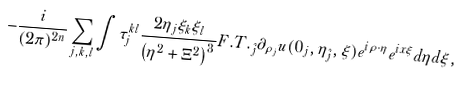<formula> <loc_0><loc_0><loc_500><loc_500>- \frac { i } { ( 2 \pi ) ^ { 2 n } } \sum _ { j , k , l } & \int \tau _ { j } ^ { k l } \frac { 2 \eta _ { j } \xi _ { k } \xi _ { l } } { \left ( \eta ^ { 2 } + \Xi ^ { 2 } \right ) ^ { 3 } } F . T . _ { \hat { j } } \partial _ { \rho _ { j } } u ( 0 _ { j } , \eta _ { \hat { j } } , \xi ) e ^ { i \rho \cdot \eta } e ^ { i x \xi } d \eta d \xi ,</formula> 